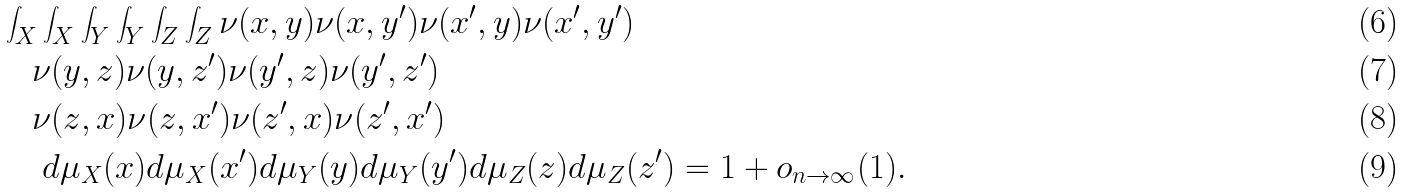<formula> <loc_0><loc_0><loc_500><loc_500>& \int _ { X } \int _ { X } \int _ { Y } \int _ { Y } \int _ { Z } \int _ { Z } \nu ( x , y ) \nu ( x , y ^ { \prime } ) \nu ( x ^ { \prime } , y ) \nu ( x ^ { \prime } , y ^ { \prime } ) \\ & \quad \nu ( y , z ) \nu ( y , z ^ { \prime } ) \nu ( y ^ { \prime } , z ) \nu ( y ^ { \prime } , z ^ { \prime } ) \\ & \quad \nu ( z , x ) \nu ( z , x ^ { \prime } ) \nu ( z ^ { \prime } , x ) \nu ( z ^ { \prime } , x ^ { \prime } ) \\ & \quad \ d \mu _ { X } ( x ) d \mu _ { X } ( x ^ { \prime } ) d \mu _ { Y } ( y ) d \mu _ { Y } ( y ^ { \prime } ) d \mu _ { Z } ( z ) d \mu _ { Z } ( z ^ { \prime } ) = 1 + o _ { n \to \infty } ( 1 ) .</formula> 